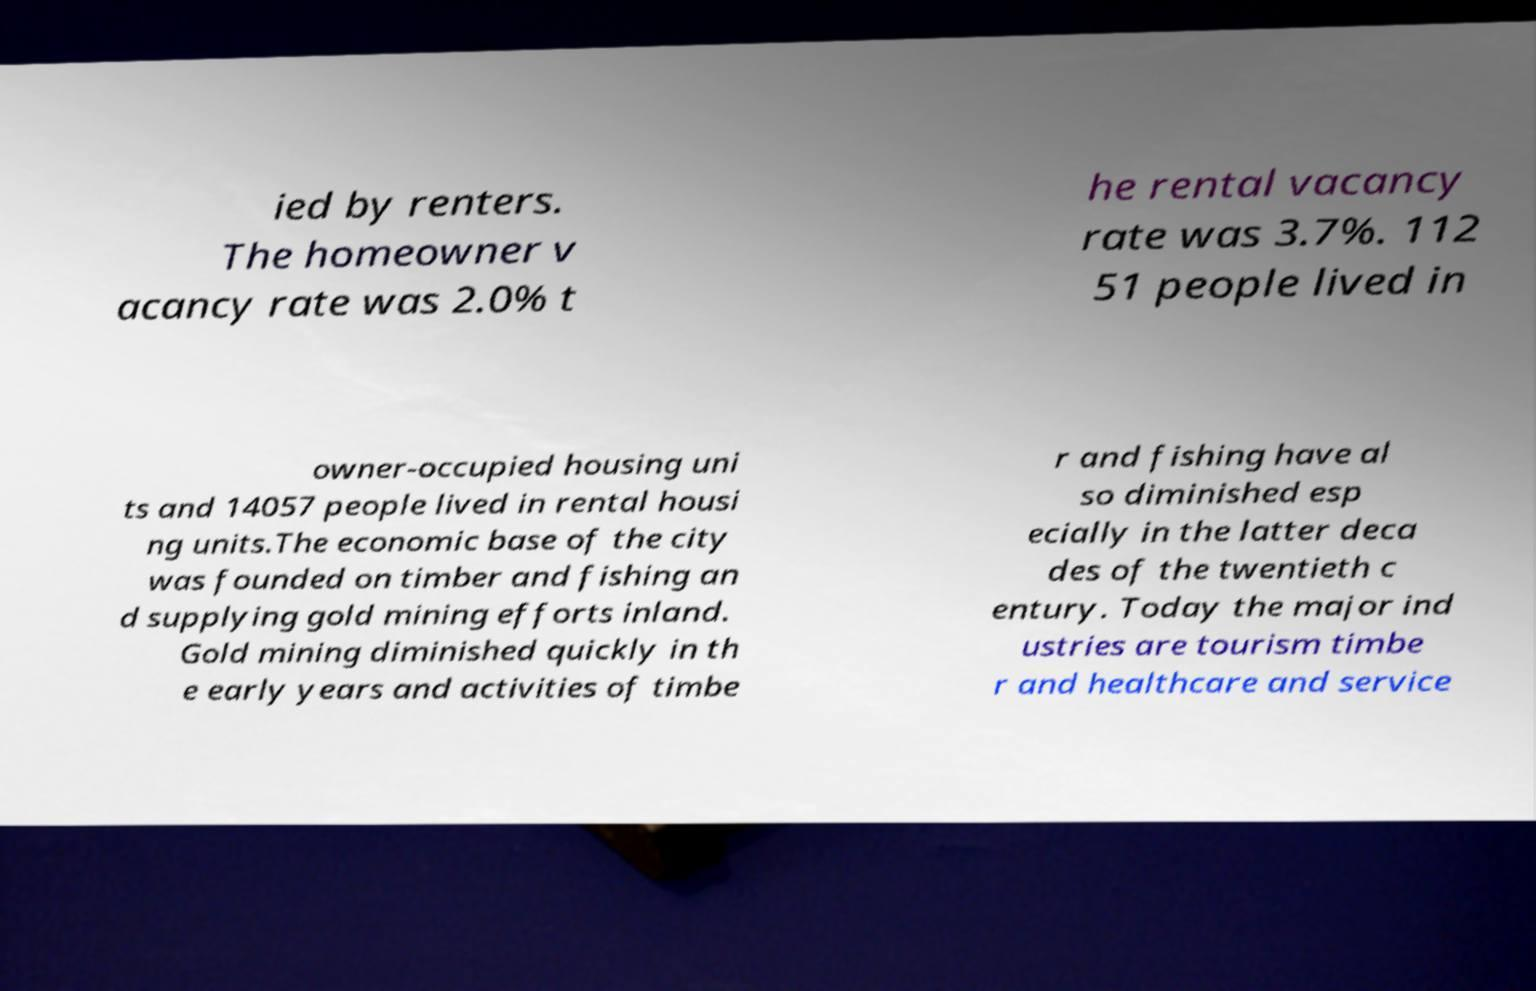I need the written content from this picture converted into text. Can you do that? ied by renters. The homeowner v acancy rate was 2.0% t he rental vacancy rate was 3.7%. 112 51 people lived in owner-occupied housing uni ts and 14057 people lived in rental housi ng units.The economic base of the city was founded on timber and fishing an d supplying gold mining efforts inland. Gold mining diminished quickly in th e early years and activities of timbe r and fishing have al so diminished esp ecially in the latter deca des of the twentieth c entury. Today the major ind ustries are tourism timbe r and healthcare and service 